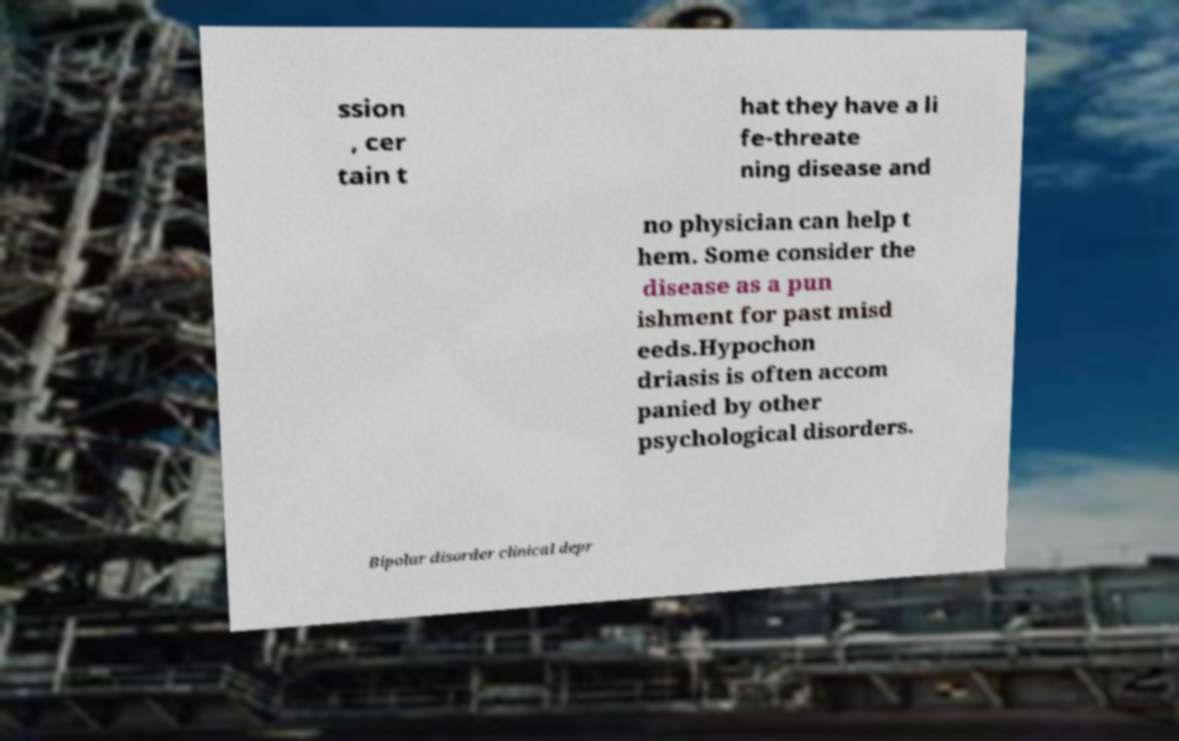For documentation purposes, I need the text within this image transcribed. Could you provide that? ssion , cer tain t hat they have a li fe-threate ning disease and no physician can help t hem. Some consider the disease as a pun ishment for past misd eeds.Hypochon driasis is often accom panied by other psychological disorders. Bipolar disorder clinical depr 